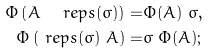Convert formula to latex. <formula><loc_0><loc_0><loc_500><loc_500>\Phi \left ( A \ \ r e p s ( \sigma ) \right ) = & \Phi ( A ) \ \sigma , \\ \Phi \left ( \ r e p s ( \sigma ) \ A \right ) = & \sigma \ \Phi ( A ) ;</formula> 